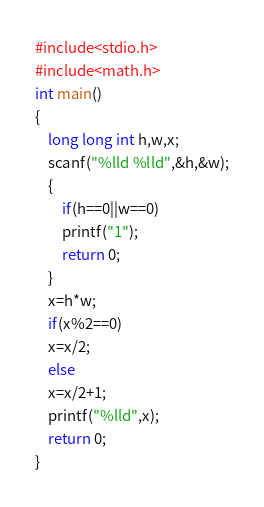<code> <loc_0><loc_0><loc_500><loc_500><_C_>#include<stdio.h>
#include<math.h>
int main()
{
	long long int h,w,x;
	scanf("%lld %lld",&h,&w);
	{
		if(h==0||w==0)
		printf("1");
		return 0;
	}
	x=h*w;
	if(x%2==0)
	x=x/2;
	else
	x=x/2+1;
	printf("%lld",x);
	return 0;
}
</code> 